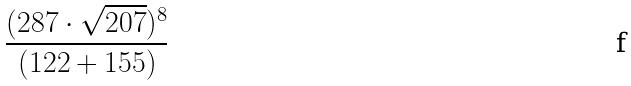Convert formula to latex. <formula><loc_0><loc_0><loc_500><loc_500>\frac { ( 2 8 7 \cdot \sqrt { 2 0 7 } ) ^ { 8 } } { ( 1 2 2 + 1 5 5 ) }</formula> 